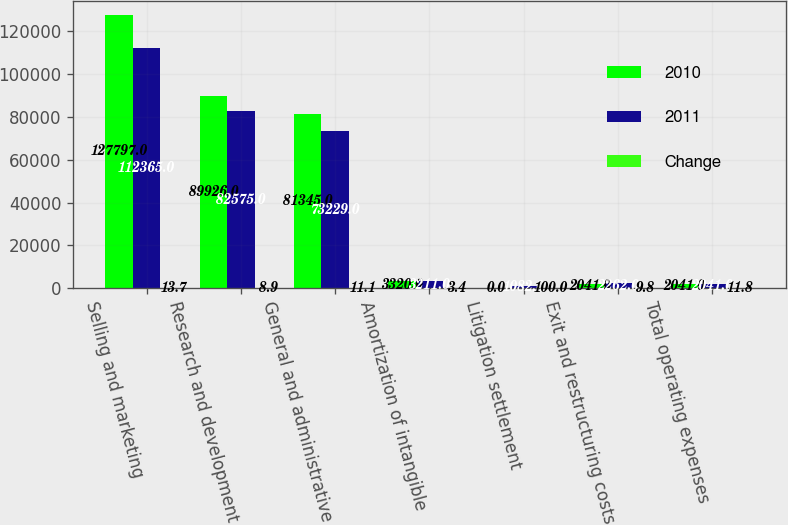Convert chart. <chart><loc_0><loc_0><loc_500><loc_500><stacked_bar_chart><ecel><fcel>Selling and marketing<fcel>Research and development<fcel>General and administrative<fcel>Amortization of intangible<fcel>Litigation settlement<fcel>Exit and restructuring costs<fcel>Total operating expenses<nl><fcel>2010<fcel>127797<fcel>89926<fcel>81345<fcel>3320<fcel>0<fcel>2041<fcel>2041<nl><fcel>2011<fcel>112365<fcel>82575<fcel>73229<fcel>3211<fcel>1082<fcel>2262<fcel>2041<nl><fcel>Change<fcel>13.7<fcel>8.9<fcel>11.1<fcel>3.4<fcel>100<fcel>9.8<fcel>11.8<nl></chart> 